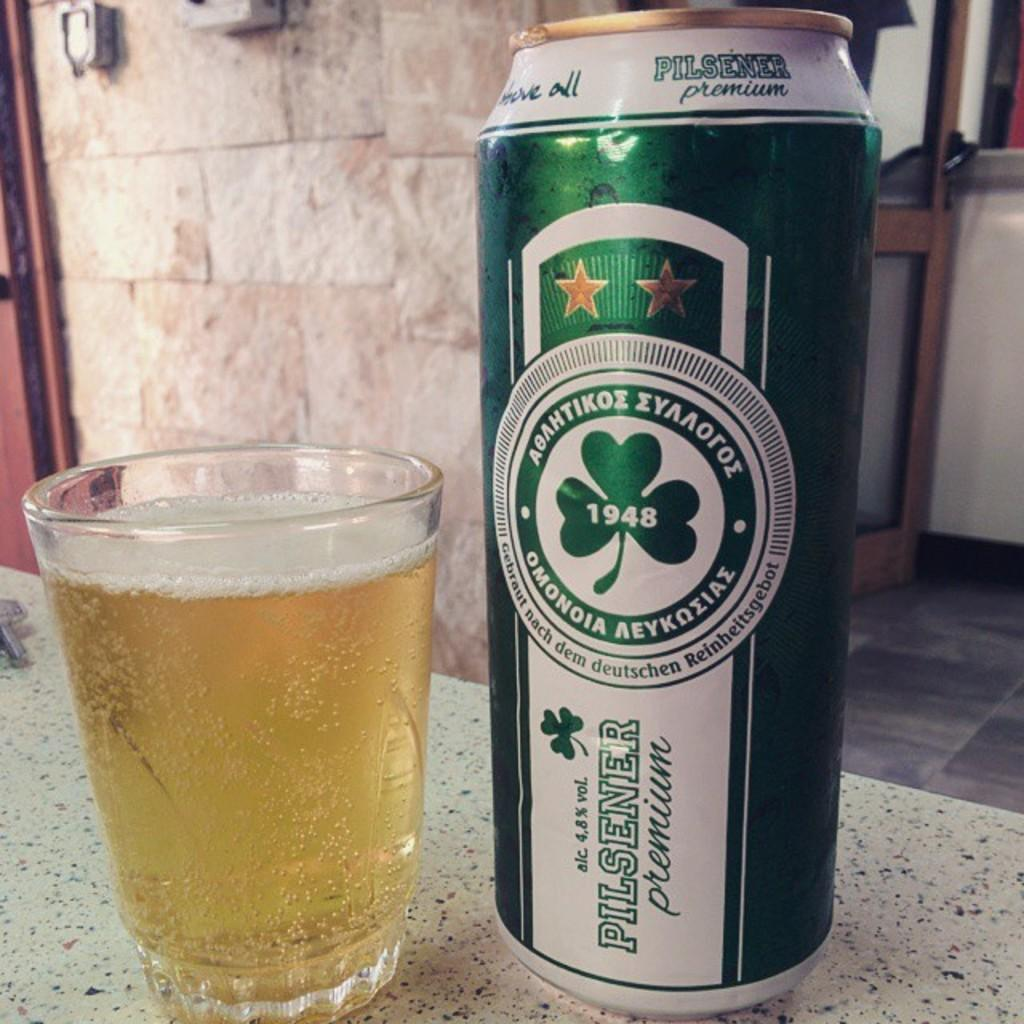<image>
Write a terse but informative summary of the picture. Green beer bottle for Pilsener Premium next to a cup of beer. 